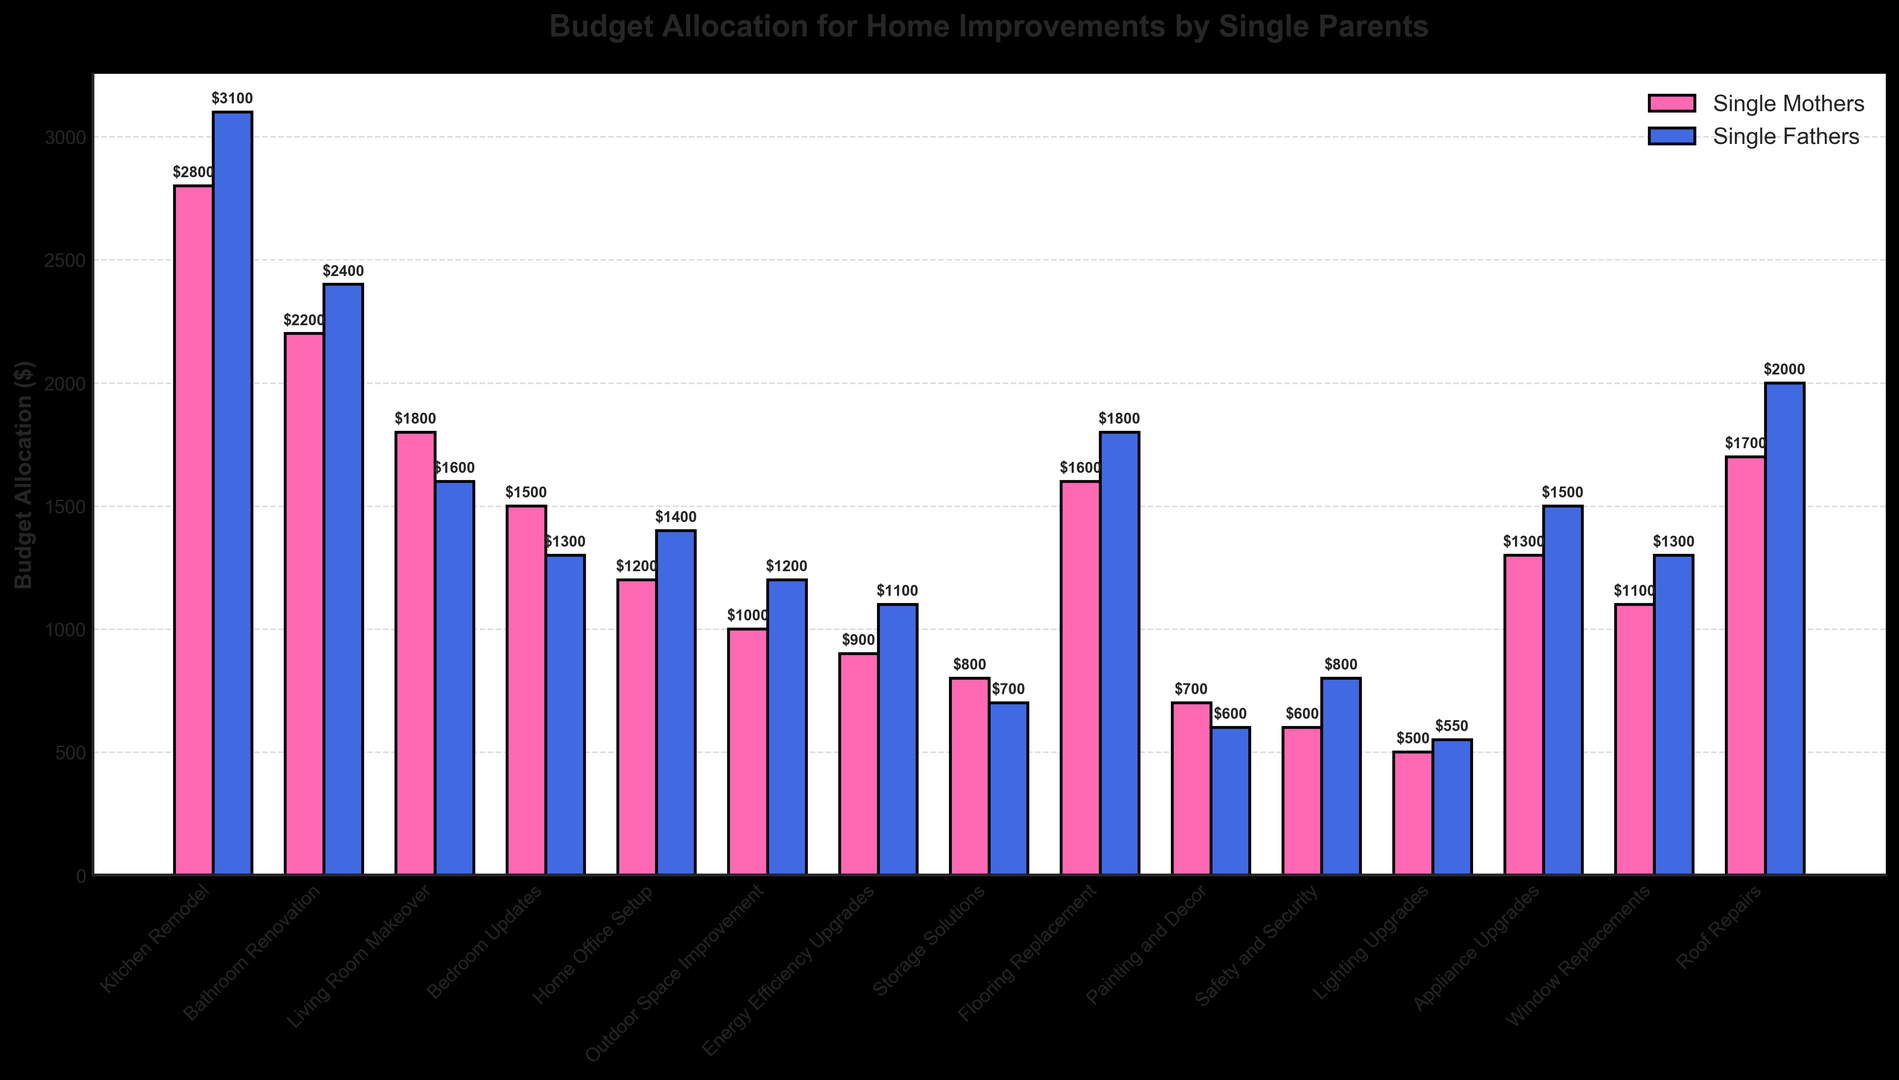Which project type has the highest budget allocation for single fathers? By looking at the height of the bars labeled for single fathers, the Kitchen Remodel bar is the tallest.
Answer: Kitchen Remodel Which project type has the smallest budget allocation for single mothers? By examining the height of the bars labeled for single mothers, the smallest bar corresponds to Lighting Upgrades.
Answer: Lighting Upgrades What is the total budget allocation for single mothers for Kitchen Remodel and Bathroom Renovation combined? Sum of the budget allocations for Kitchen Remodel ($2800) and Bathroom Renovation ($2200) for single mothers is $2800 + $2200.
Answer: $5000 How much more do single fathers allocate for Home Office Setup compared to single mothers? The budget allocation for Home Office Setup is $1400 for single fathers and $1200 for single mothers. The difference is $1400 - $1200.
Answer: $200 Which gender allocates more budget for the Outdoor Space Improvement project? By how much? Single fathers allocate $1200 and single mothers allocate $1000. The difference is $1200 - $1000.
Answer: Single fathers by $200 Which project type shows the largest absolute difference in budget allocation between single mothers and single fathers? By comparing the absolute differences across all project types, the highest difference is for Kitchen Remodel ($3100 - $2800 = $300).
Answer: Kitchen Remodel What's the average budget allocation for single fathers across all project types? Sum of all budget allocations for single fathers is $3100 + $2400 + $1600 + $1300 + $1400 + $1200 + $1100 + $700 + $1800 + $600 + $800 + $550 + $1500 + $1300 + $2000 = $21750, so the average is $21750 / 15.
Answer: $1450 What is the median budget allocation for single mothers? After arranging the budget allocations in ascending order ($500, $600, $700, $800, $900, $1000, $1200, $1300, $1500, $1600, $1700, $1800, $2200, $2800), the middle number (8th in order) is $1300.
Answer: $1300 Is there any project type where single mothers allocate more budget than single fathers? If so, which one? By comparing the budget allocations, Living Room Makeover ($1800 vs. $1600) and Storage Solutions ($800 vs. $700) show higher allocations for single mothers.
Answer: Living Room Makeover, Storage Solutions Which project type shows the smallest difference in budget allocation between single mothers and single fathers? By comparing the budget allocations for each project type, the smallest difference is for Lighting Upgrades ($550 - $500 = $50).
Answer: Lighting Upgrades 